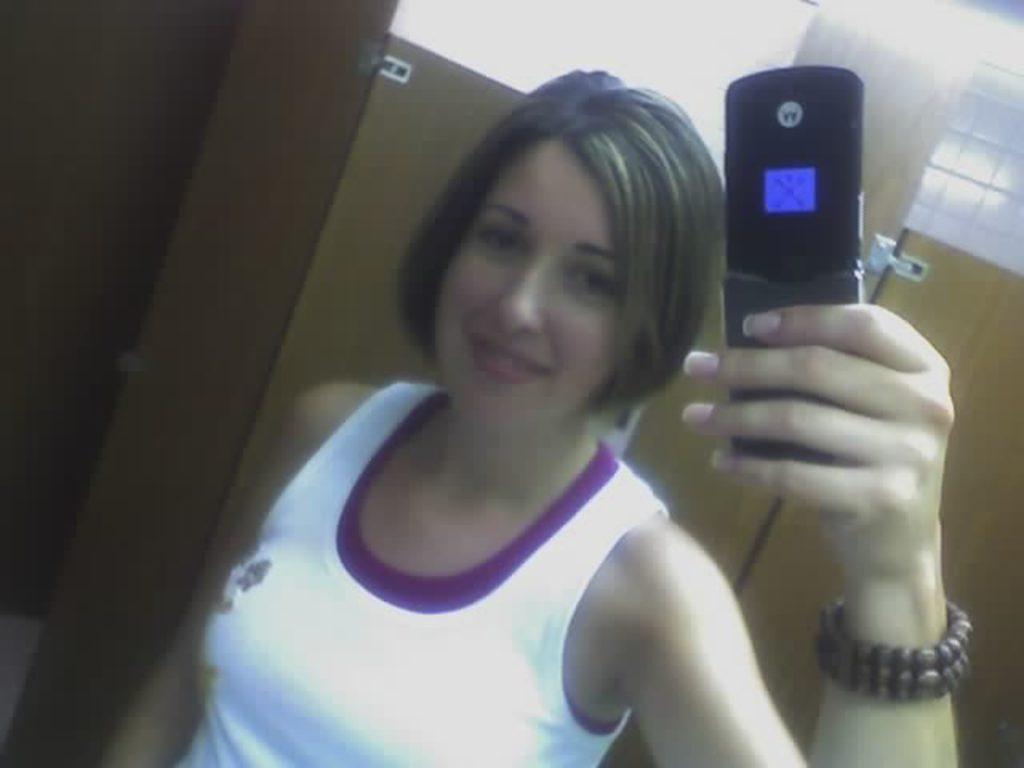How would you summarize this image in a sentence or two? There is a lady holding a phone in the foreground area of the image, it seems like a door in the background. 